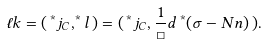Convert formula to latex. <formula><loc_0><loc_0><loc_500><loc_500>\ell k = ( \, ^ { * } j _ { C } , ^ { * } l \, ) = ( \, ^ { * } j _ { C } , \frac { 1 } { \Box } d \, ^ { * } ( \sigma - N n ) \, ) .</formula> 